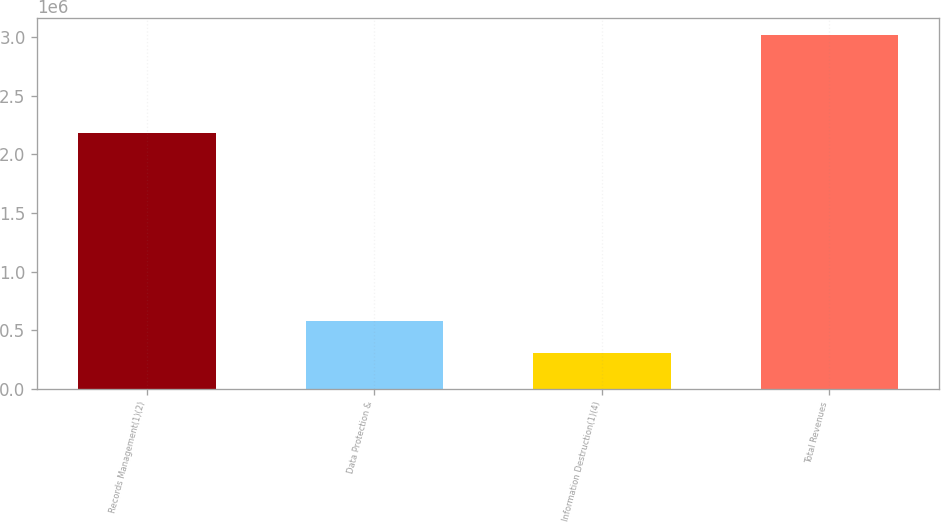Convert chart to OTSL. <chart><loc_0><loc_0><loc_500><loc_500><bar_chart><fcel>Records Management(1)(2)<fcel>Data Protection &<fcel>Information Destruction(1)(4)<fcel>Total Revenues<nl><fcel>2.18315e+06<fcel>579496<fcel>308917<fcel>3.0147e+06<nl></chart> 